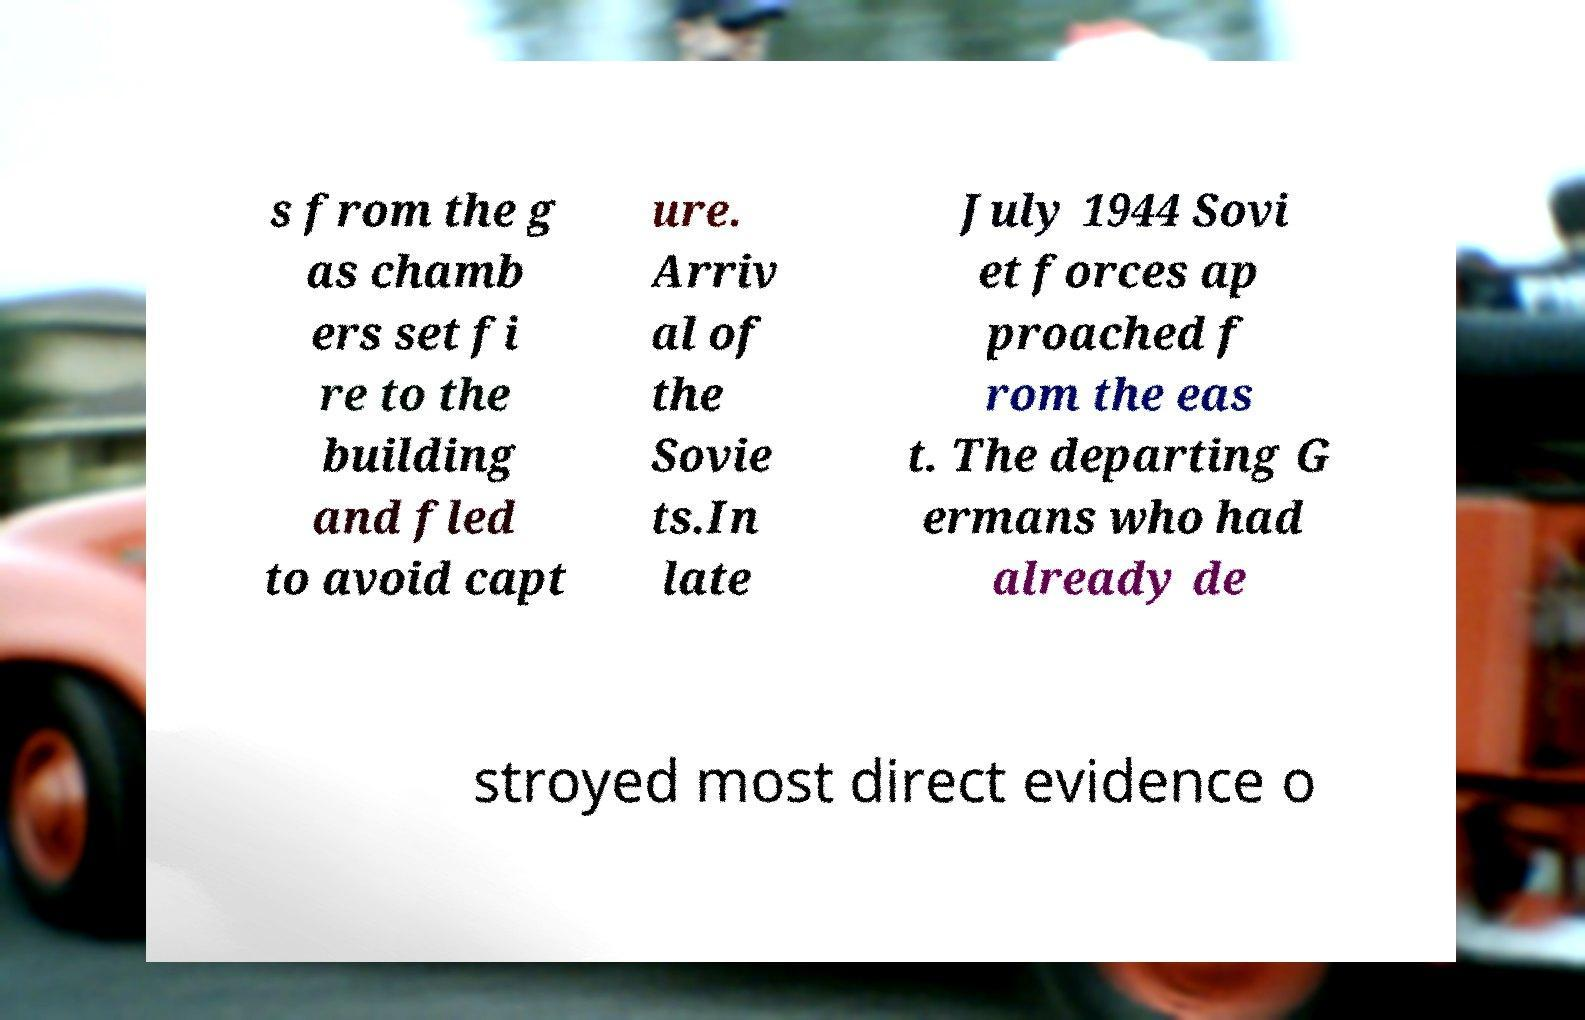There's text embedded in this image that I need extracted. Can you transcribe it verbatim? s from the g as chamb ers set fi re to the building and fled to avoid capt ure. Arriv al of the Sovie ts.In late July 1944 Sovi et forces ap proached f rom the eas t. The departing G ermans who had already de stroyed most direct evidence o 